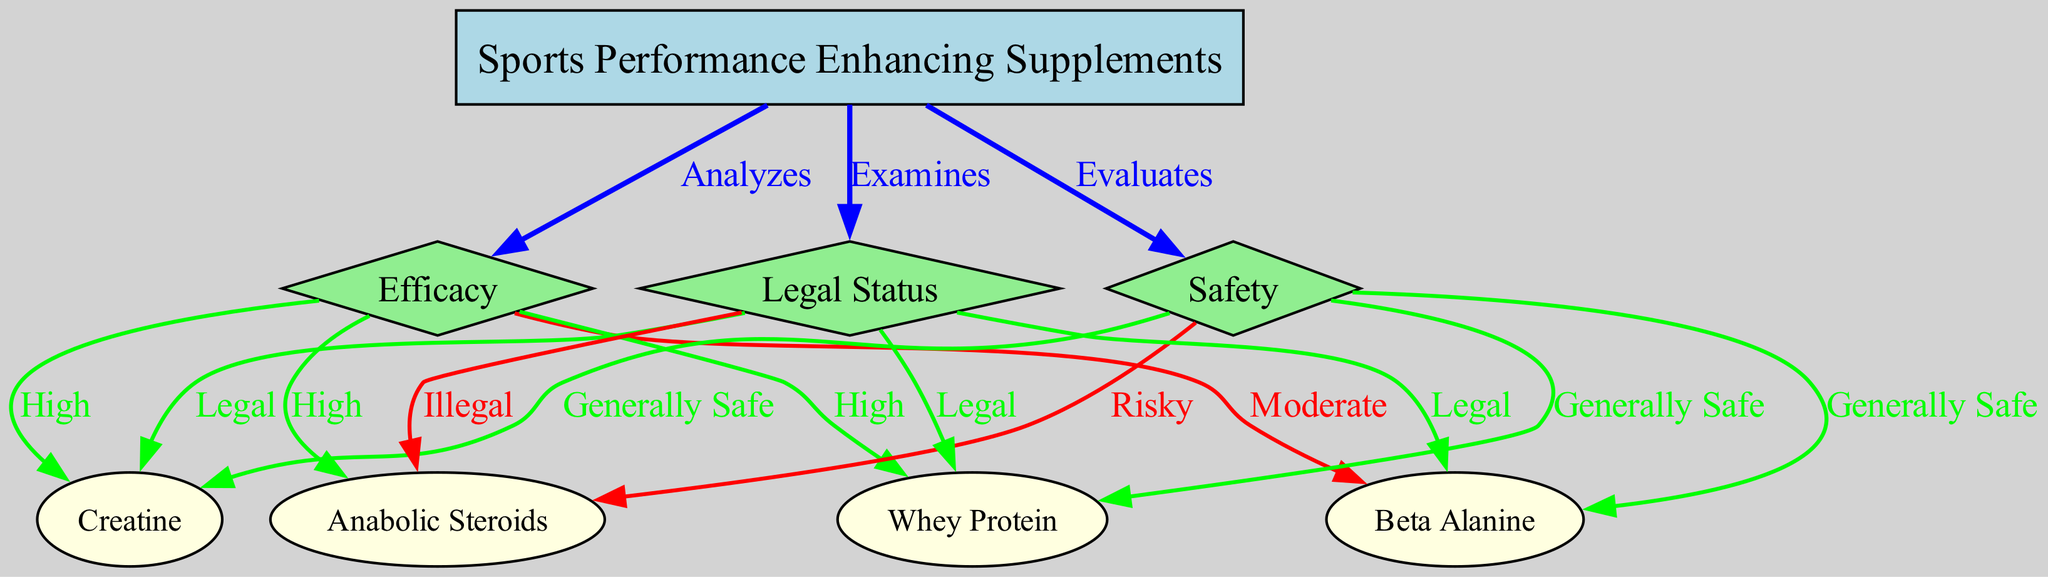What are the main categories evaluated for sports performance enhancing supplements? The diagram shows three main categories evaluated for supplements: efficacy, safety, and legal status. These categories are directly connected to the main node 'Sports Performance Enhancing Supplements.'
Answer: efficacy, safety, legal status Which supplement is categorized as "Generally Safe"? The connections from the 'safety' node indicate that creatine, beta alanine, and whey protein are labeled as "Generally Safe." This can be verified by looking at the edges extending from the 'safety' node.
Answer: creatine, beta alanine, whey protein How many supplements are classified as having "High" efficacy? By examining the 'efficacy' node, we see that it connects to four supplements: creatine, beta alanine, whey protein, and anabolic steroids. Among these, three are marked with "High" efficacy as indicated by the edge labels to creatine, whey protein, and anabolic steroids.
Answer: three What is the legal status of anabolic steroids according to the diagram? The diagram shows a direct edge from the 'legal status' node to anabolic steroids, which is labeled "Illegal." Thus, the legal status of anabolic steroids is clearly identified.
Answer: Illegal Which supplement has a moderate efficacy rating? The diagram shows that beta alanine is connected to the 'efficacy' node with the label "Moderate." This indicates its performance level is not as high as the others.
Answer: Beta Alanine Which supplement appears in all three categories (efficacy, safety, and legal status)? By reviewing the edges leading from the 'supplements' node, it is clear that all supplements are evaluated for efficacy, safety, and legal status. However, to identify the one appearing in all three categories, we can refer to the connections for creatine, which has high efficacy, is generally safe, and is legal.
Answer: Creatine What color is used to represent nodes related to efficacy in the diagram? The efficacy nodes are represented in green according to the diagram color coding for the different kinds of nodes. The color address the relationships between the supplements and their efficacy evaluations.
Answer: green Which supplement is evaluated as risky in terms of safety? The edges extending from the 'safety' node indicate that anabolic steroids are labeled "Risky," denoting potential health hazards associated with their use as a performance enhancing substance.
Answer: Anabolic Steroids 